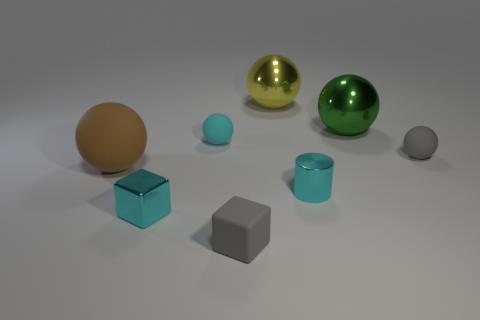Are there any small cubes that have the same material as the small cyan ball?
Your answer should be very brief. Yes. What shape is the large yellow thing?
Provide a succinct answer. Sphere. There is another big thing that is made of the same material as the yellow object; what color is it?
Ensure brevity in your answer.  Green. What number of purple things are tiny cylinders or tiny cubes?
Your answer should be very brief. 0. Is the number of tiny blue rubber things greater than the number of cylinders?
Ensure brevity in your answer.  No. How many objects are either small gray rubber spheres that are right of the small cyan ball or gray rubber things behind the brown rubber ball?
Provide a short and direct response. 1. There is a metal sphere that is the same size as the green thing; what is its color?
Your answer should be compact. Yellow. Is the cyan cylinder made of the same material as the small gray block?
Offer a terse response. No. What material is the small sphere left of the tiny cube that is in front of the metallic cube?
Give a very brief answer. Rubber. Is the number of balls that are behind the cyan sphere greater than the number of large yellow shiny balls?
Make the answer very short. Yes. 